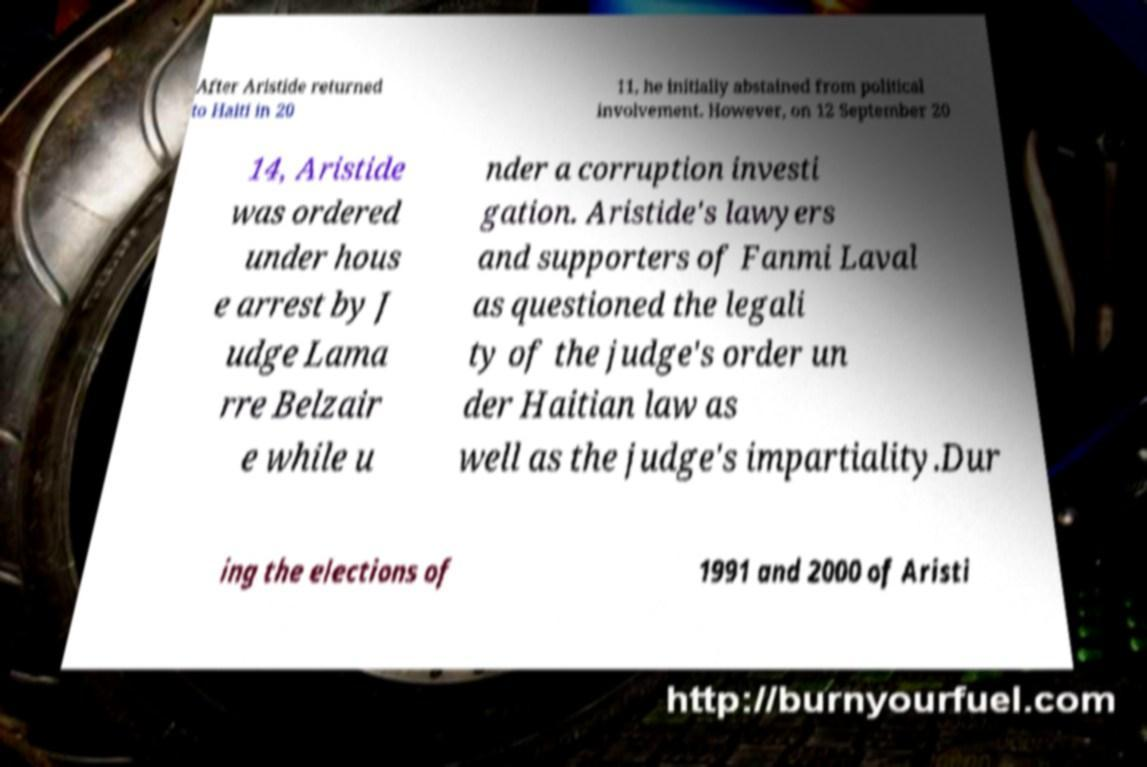I need the written content from this picture converted into text. Can you do that? After Aristide returned to Haiti in 20 11, he initially abstained from political involvement. However, on 12 September 20 14, Aristide was ordered under hous e arrest by J udge Lama rre Belzair e while u nder a corruption investi gation. Aristide's lawyers and supporters of Fanmi Laval as questioned the legali ty of the judge's order un der Haitian law as well as the judge's impartiality.Dur ing the elections of 1991 and 2000 of Aristi 